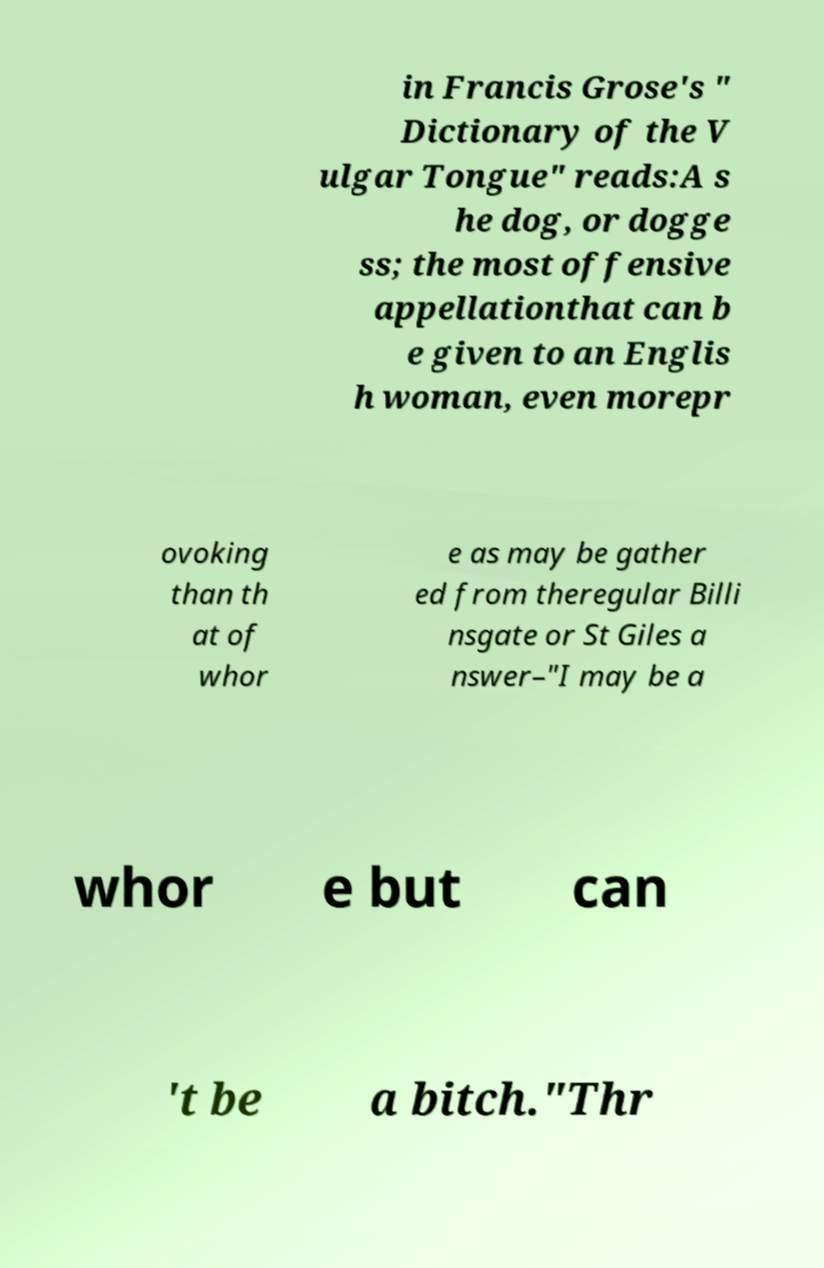Please identify and transcribe the text found in this image. in Francis Grose's " Dictionary of the V ulgar Tongue" reads:A s he dog, or dogge ss; the most offensive appellationthat can b e given to an Englis h woman, even morepr ovoking than th at of whor e as may be gather ed from theregular Billi nsgate or St Giles a nswer–"I may be a whor e but can 't be a bitch."Thr 